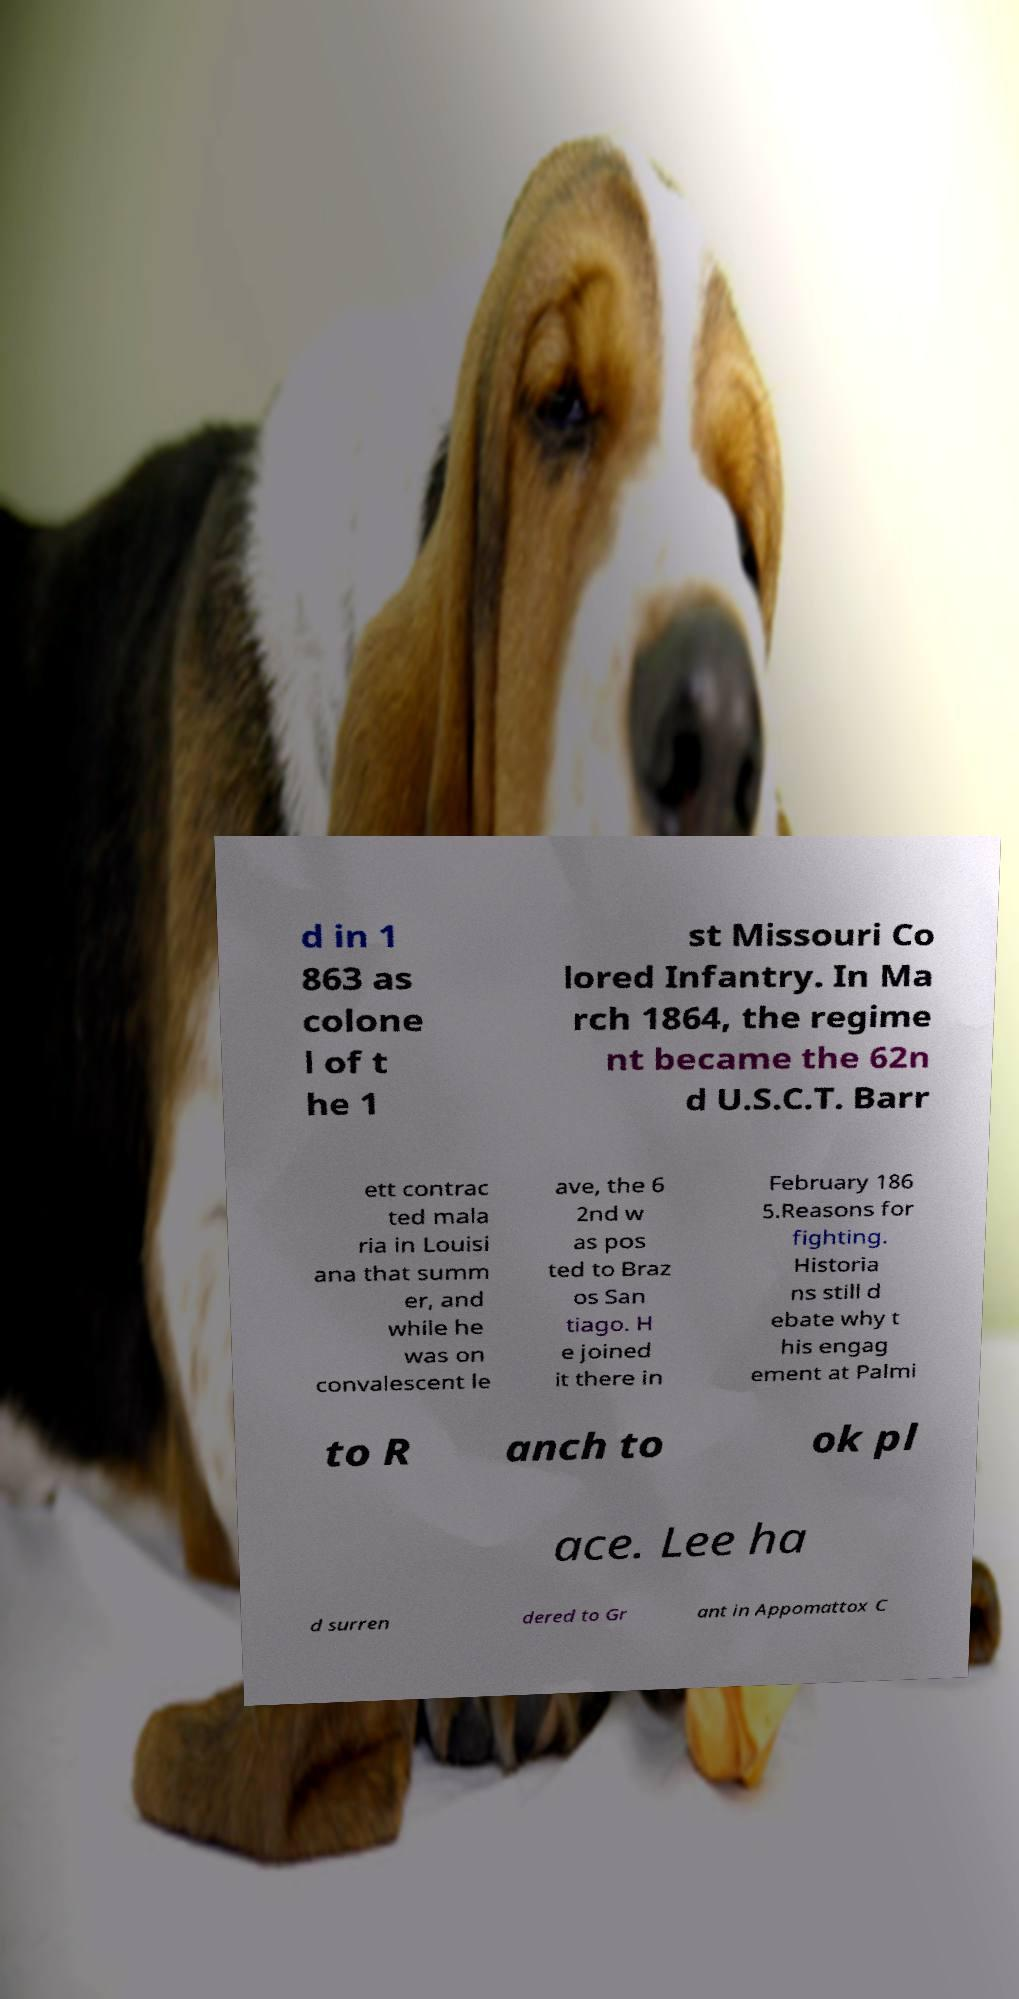Can you read and provide the text displayed in the image?This photo seems to have some interesting text. Can you extract and type it out for me? d in 1 863 as colone l of t he 1 st Missouri Co lored Infantry. In Ma rch 1864, the regime nt became the 62n d U.S.C.T. Barr ett contrac ted mala ria in Louisi ana that summ er, and while he was on convalescent le ave, the 6 2nd w as pos ted to Braz os San tiago. H e joined it there in February 186 5.Reasons for fighting. Historia ns still d ebate why t his engag ement at Palmi to R anch to ok pl ace. Lee ha d surren dered to Gr ant in Appomattox C 